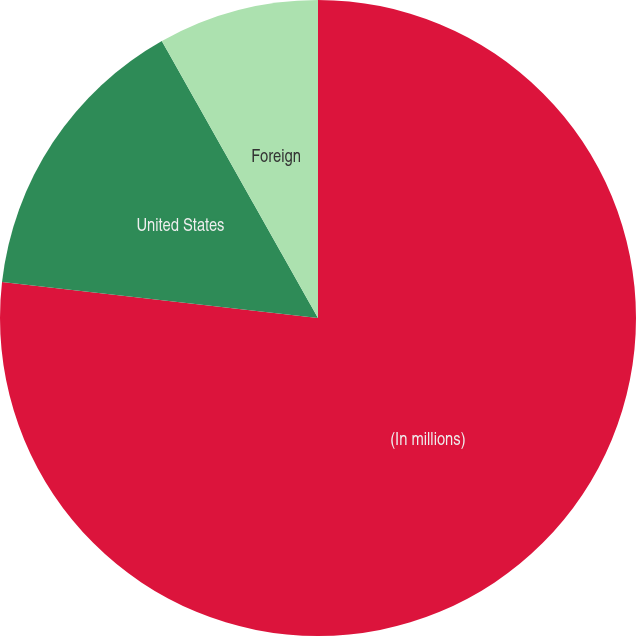Convert chart to OTSL. <chart><loc_0><loc_0><loc_500><loc_500><pie_chart><fcel>(In millions)<fcel>United States<fcel>Foreign<nl><fcel>76.8%<fcel>15.03%<fcel>8.17%<nl></chart> 